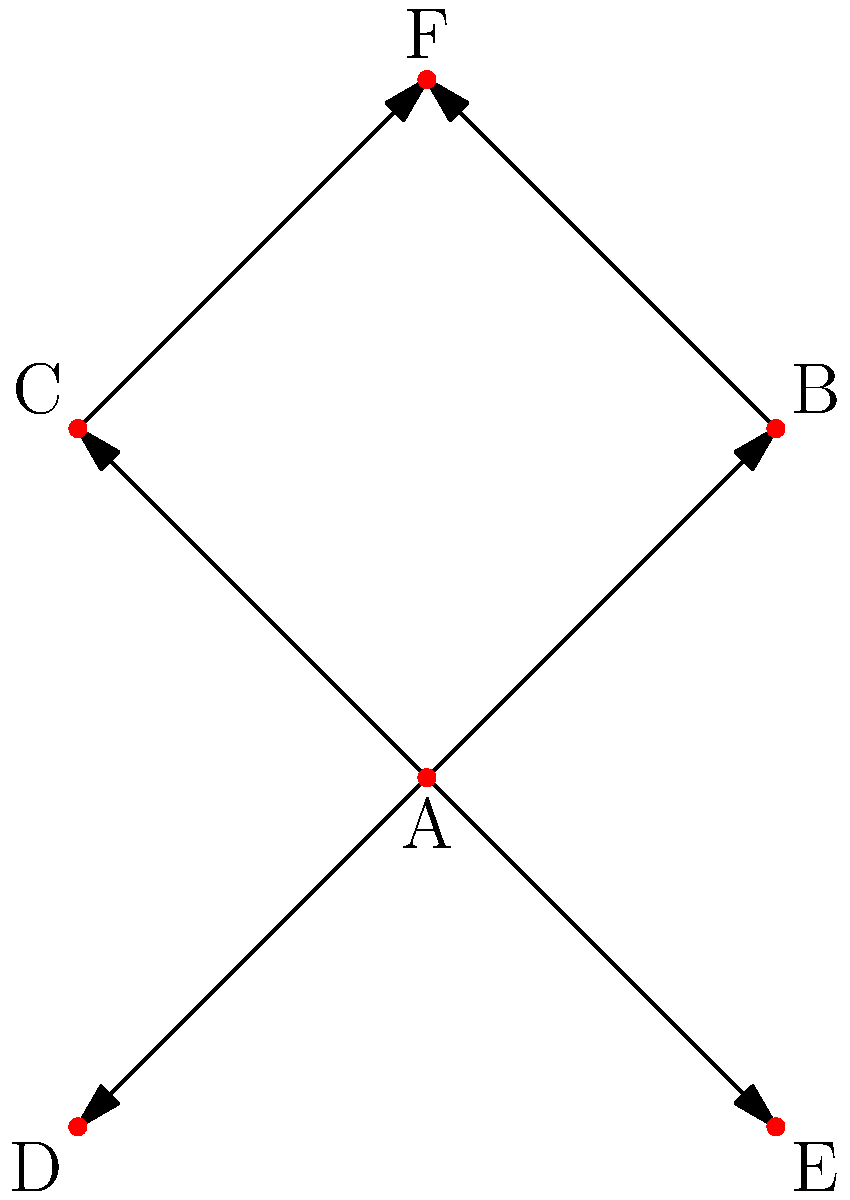In the support network graph shown above, vertex A represents you as a supportive friend. If you were to become unavailable (i.e., vertex A is removed), how would this affect the network's connectivity? What graph theory concept best describes the importance of your role in this network? To analyze the impact of removing vertex A on the network's connectivity, we need to follow these steps:

1. Observe the current structure:
   - The graph has 6 vertices (A, B, C, D, E, F) and 6 edges.
   - Vertex A is connected to B, C, D, and E.
   - Vertices B and C are connected to F.

2. Remove vertex A and its associated edges:
   - This leaves us with 5 vertices (B, C, D, E, F) and only 2 edges (B--F and C--F).

3. Analyze the resulting graph:
   - The graph is now disconnected, forming three components:
     a. Component 1: B and F
     b. Component 2: C and F
     c. Component 3: D (isolated)
     d. Component 4: E (isolated)

4. Identify the graph theory concept:
   - The concept that best describes the importance of vertex A in this network is "cut vertex" or "articulation point."
   - A cut vertex is a vertex whose removal increases the number of connected components in a graph.

5. Understand the implications:
   - As a supportive friend (vertex A), you play a crucial role in maintaining the connectivity of the support network.
   - Your removal would disconnect the graph, isolating some individuals (D and E) and reducing the overall communication and support flow in the network.

This analysis demonstrates the significance of your role as a supportive friend in maintaining the resilience and connectivity of the support network.
Answer: Cut vertex 